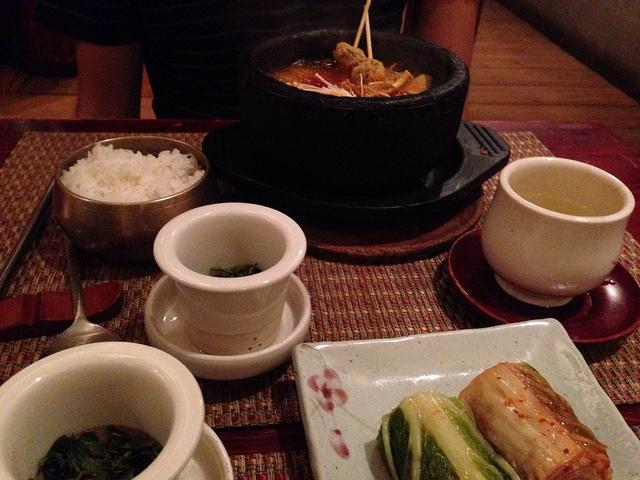What is the black pot used for? meat 